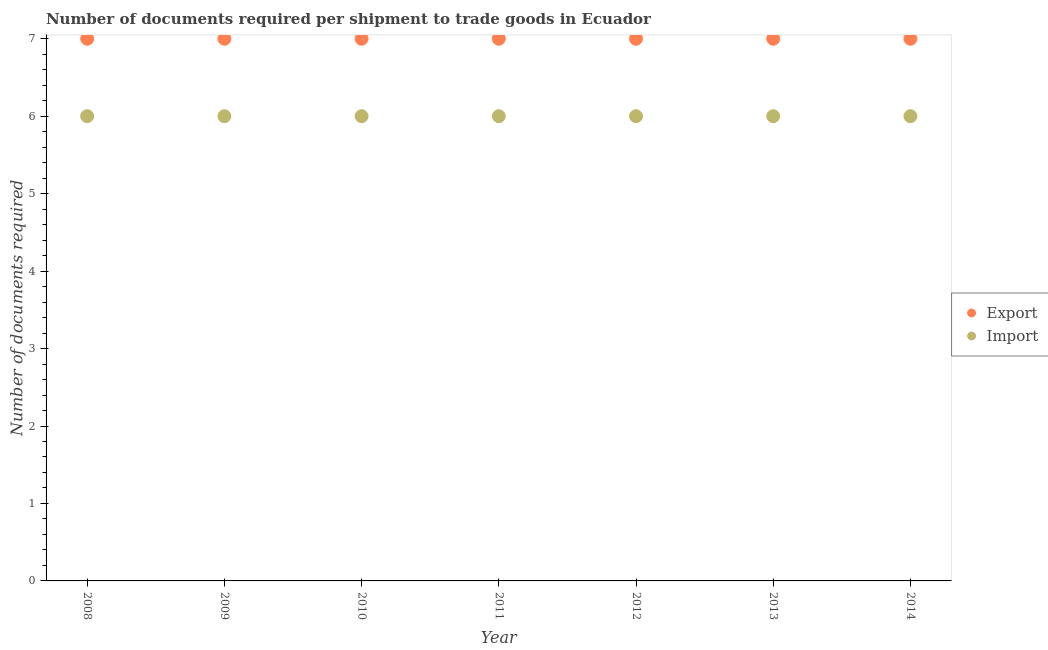Is the number of dotlines equal to the number of legend labels?
Ensure brevity in your answer.  Yes. Across all years, what is the maximum number of documents required to import goods?
Make the answer very short. 6. Across all years, what is the minimum number of documents required to export goods?
Make the answer very short. 7. In which year was the number of documents required to import goods maximum?
Make the answer very short. 2008. In which year was the number of documents required to export goods minimum?
Provide a short and direct response. 2008. What is the total number of documents required to import goods in the graph?
Offer a terse response. 42. What is the difference between the number of documents required to export goods in 2009 and that in 2011?
Provide a succinct answer. 0. What is the difference between the number of documents required to import goods in 2014 and the number of documents required to export goods in 2012?
Offer a terse response. -1. In the year 2013, what is the difference between the number of documents required to import goods and number of documents required to export goods?
Ensure brevity in your answer.  -1. In how many years, is the number of documents required to export goods greater than 5.2?
Give a very brief answer. 7. What is the ratio of the number of documents required to import goods in 2010 to that in 2014?
Provide a short and direct response. 1. Does the number of documents required to export goods monotonically increase over the years?
Your response must be concise. No. Is the number of documents required to export goods strictly greater than the number of documents required to import goods over the years?
Your answer should be compact. Yes. Is the number of documents required to import goods strictly less than the number of documents required to export goods over the years?
Provide a short and direct response. Yes. How many dotlines are there?
Your response must be concise. 2. Does the graph contain any zero values?
Provide a succinct answer. No. Where does the legend appear in the graph?
Offer a terse response. Center right. How are the legend labels stacked?
Provide a short and direct response. Vertical. What is the title of the graph?
Offer a terse response. Number of documents required per shipment to trade goods in Ecuador. What is the label or title of the Y-axis?
Your response must be concise. Number of documents required. What is the Number of documents required in Export in 2008?
Provide a succinct answer. 7. What is the Number of documents required of Import in 2008?
Offer a terse response. 6. What is the Number of documents required of Export in 2010?
Offer a very short reply. 7. What is the Number of documents required in Import in 2011?
Your response must be concise. 6. What is the Number of documents required in Export in 2012?
Offer a terse response. 7. What is the Number of documents required in Import in 2013?
Give a very brief answer. 6. What is the Number of documents required in Export in 2014?
Give a very brief answer. 7. Across all years, what is the maximum Number of documents required of Export?
Give a very brief answer. 7. Across all years, what is the maximum Number of documents required of Import?
Ensure brevity in your answer.  6. Across all years, what is the minimum Number of documents required in Export?
Your response must be concise. 7. Across all years, what is the minimum Number of documents required in Import?
Ensure brevity in your answer.  6. What is the total Number of documents required in Export in the graph?
Offer a very short reply. 49. What is the total Number of documents required of Import in the graph?
Provide a short and direct response. 42. What is the difference between the Number of documents required in Import in 2008 and that in 2009?
Your answer should be compact. 0. What is the difference between the Number of documents required in Import in 2008 and that in 2012?
Provide a short and direct response. 0. What is the difference between the Number of documents required in Export in 2009 and that in 2010?
Keep it short and to the point. 0. What is the difference between the Number of documents required of Import in 2009 and that in 2010?
Provide a succinct answer. 0. What is the difference between the Number of documents required of Import in 2009 and that in 2011?
Provide a succinct answer. 0. What is the difference between the Number of documents required of Export in 2009 and that in 2012?
Offer a very short reply. 0. What is the difference between the Number of documents required of Import in 2009 and that in 2012?
Make the answer very short. 0. What is the difference between the Number of documents required of Export in 2009 and that in 2013?
Ensure brevity in your answer.  0. What is the difference between the Number of documents required of Export in 2010 and that in 2011?
Your answer should be compact. 0. What is the difference between the Number of documents required in Import in 2010 and that in 2011?
Give a very brief answer. 0. What is the difference between the Number of documents required in Export in 2010 and that in 2014?
Ensure brevity in your answer.  0. What is the difference between the Number of documents required in Import in 2011 and that in 2013?
Make the answer very short. 0. What is the difference between the Number of documents required in Import in 2011 and that in 2014?
Ensure brevity in your answer.  0. What is the difference between the Number of documents required of Export in 2012 and that in 2013?
Offer a very short reply. 0. What is the difference between the Number of documents required of Import in 2012 and that in 2013?
Offer a terse response. 0. What is the difference between the Number of documents required of Export in 2013 and that in 2014?
Provide a succinct answer. 0. What is the difference between the Number of documents required of Import in 2013 and that in 2014?
Offer a terse response. 0. What is the difference between the Number of documents required of Export in 2008 and the Number of documents required of Import in 2009?
Your response must be concise. 1. What is the difference between the Number of documents required of Export in 2008 and the Number of documents required of Import in 2011?
Provide a succinct answer. 1. What is the difference between the Number of documents required of Export in 2008 and the Number of documents required of Import in 2014?
Offer a terse response. 1. What is the difference between the Number of documents required in Export in 2010 and the Number of documents required in Import in 2011?
Provide a short and direct response. 1. What is the difference between the Number of documents required in Export in 2010 and the Number of documents required in Import in 2012?
Offer a terse response. 1. What is the difference between the Number of documents required in Export in 2010 and the Number of documents required in Import in 2014?
Keep it short and to the point. 1. What is the difference between the Number of documents required of Export in 2011 and the Number of documents required of Import in 2012?
Offer a very short reply. 1. What is the difference between the Number of documents required of Export in 2011 and the Number of documents required of Import in 2013?
Your response must be concise. 1. What is the difference between the Number of documents required of Export in 2013 and the Number of documents required of Import in 2014?
Offer a very short reply. 1. What is the average Number of documents required in Export per year?
Your answer should be compact. 7. In the year 2008, what is the difference between the Number of documents required in Export and Number of documents required in Import?
Provide a short and direct response. 1. In the year 2010, what is the difference between the Number of documents required in Export and Number of documents required in Import?
Your answer should be very brief. 1. In the year 2013, what is the difference between the Number of documents required in Export and Number of documents required in Import?
Offer a terse response. 1. What is the ratio of the Number of documents required of Export in 2008 to that in 2009?
Make the answer very short. 1. What is the ratio of the Number of documents required of Import in 2008 to that in 2010?
Your response must be concise. 1. What is the ratio of the Number of documents required in Export in 2008 to that in 2011?
Provide a succinct answer. 1. What is the ratio of the Number of documents required of Import in 2008 to that in 2012?
Make the answer very short. 1. What is the ratio of the Number of documents required in Export in 2008 to that in 2013?
Make the answer very short. 1. What is the ratio of the Number of documents required of Import in 2009 to that in 2010?
Offer a very short reply. 1. What is the ratio of the Number of documents required of Export in 2009 to that in 2012?
Give a very brief answer. 1. What is the ratio of the Number of documents required in Export in 2009 to that in 2014?
Provide a succinct answer. 1. What is the ratio of the Number of documents required in Export in 2010 to that in 2011?
Provide a short and direct response. 1. What is the ratio of the Number of documents required of Export in 2010 to that in 2012?
Provide a succinct answer. 1. What is the ratio of the Number of documents required in Import in 2010 to that in 2012?
Give a very brief answer. 1. What is the ratio of the Number of documents required of Export in 2010 to that in 2014?
Keep it short and to the point. 1. What is the ratio of the Number of documents required of Export in 2011 to that in 2012?
Your answer should be very brief. 1. What is the ratio of the Number of documents required of Import in 2011 to that in 2012?
Offer a very short reply. 1. What is the ratio of the Number of documents required of Import in 2011 to that in 2014?
Make the answer very short. 1. What is the ratio of the Number of documents required in Import in 2012 to that in 2014?
Offer a terse response. 1. What is the ratio of the Number of documents required in Export in 2013 to that in 2014?
Ensure brevity in your answer.  1. What is the ratio of the Number of documents required in Import in 2013 to that in 2014?
Your answer should be compact. 1. What is the difference between the highest and the second highest Number of documents required of Import?
Provide a succinct answer. 0. What is the difference between the highest and the lowest Number of documents required in Export?
Keep it short and to the point. 0. What is the difference between the highest and the lowest Number of documents required in Import?
Give a very brief answer. 0. 